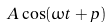<formula> <loc_0><loc_0><loc_500><loc_500>A \cos ( \omega t + p )</formula> 